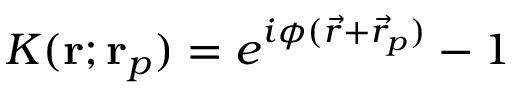Convert formula to latex. <formula><loc_0><loc_0><loc_500><loc_500>K ( r ; r _ { p } ) = e ^ { i \phi ( \vec { r } + \vec { r } _ { p } ) } - 1</formula> 